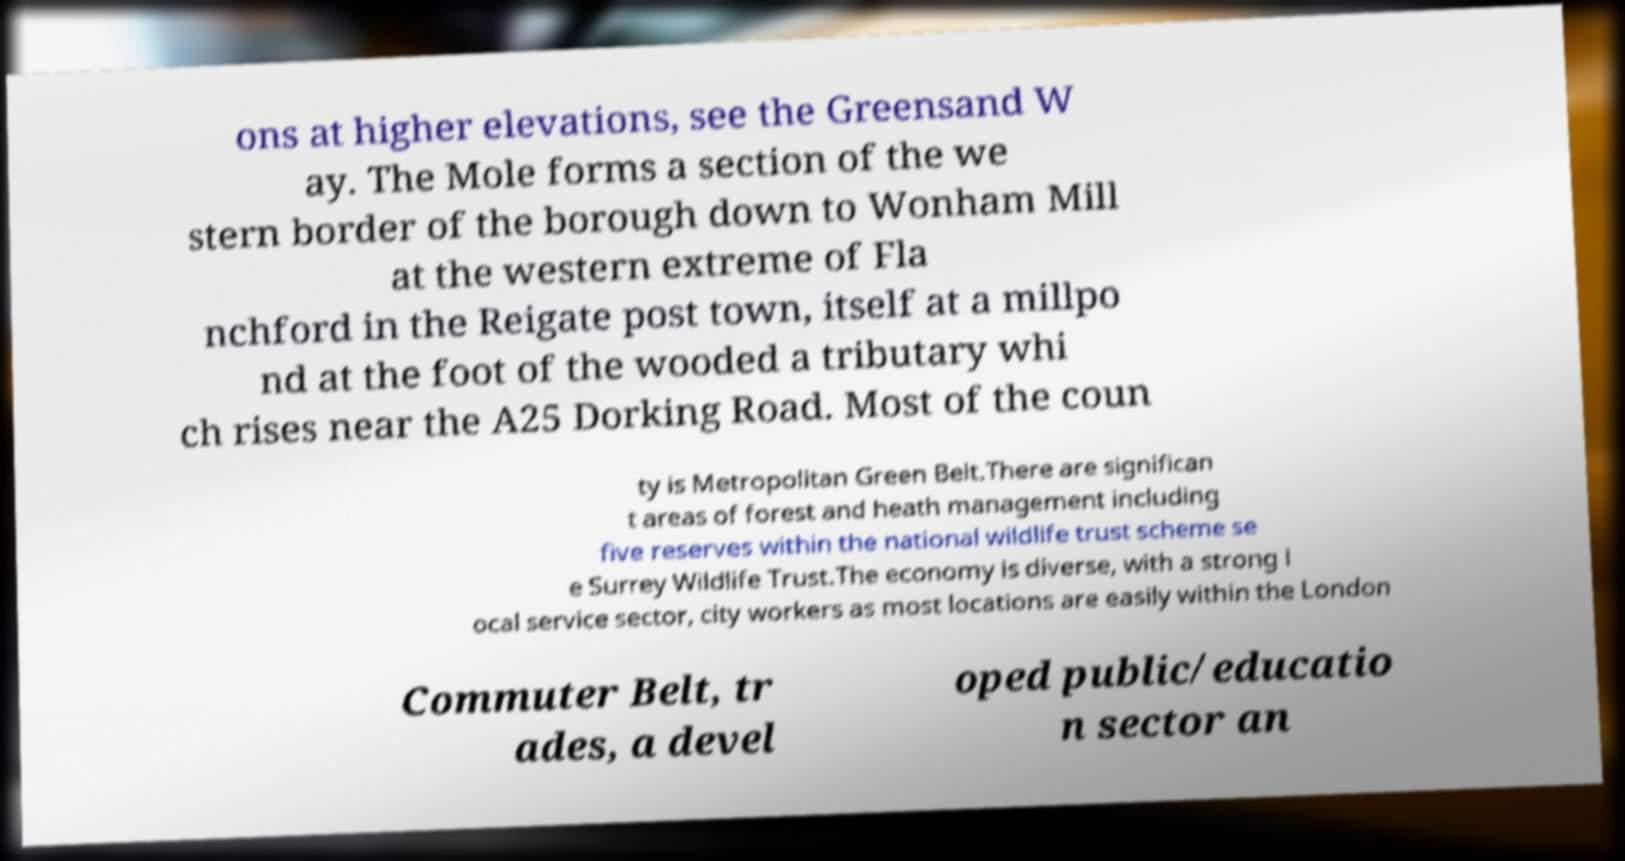I need the written content from this picture converted into text. Can you do that? ons at higher elevations, see the Greensand W ay. The Mole forms a section of the we stern border of the borough down to Wonham Mill at the western extreme of Fla nchford in the Reigate post town, itself at a millpo nd at the foot of the wooded a tributary whi ch rises near the A25 Dorking Road. Most of the coun ty is Metropolitan Green Belt.There are significan t areas of forest and heath management including five reserves within the national wildlife trust scheme se e Surrey Wildlife Trust.The economy is diverse, with a strong l ocal service sector, city workers as most locations are easily within the London Commuter Belt, tr ades, a devel oped public/educatio n sector an 